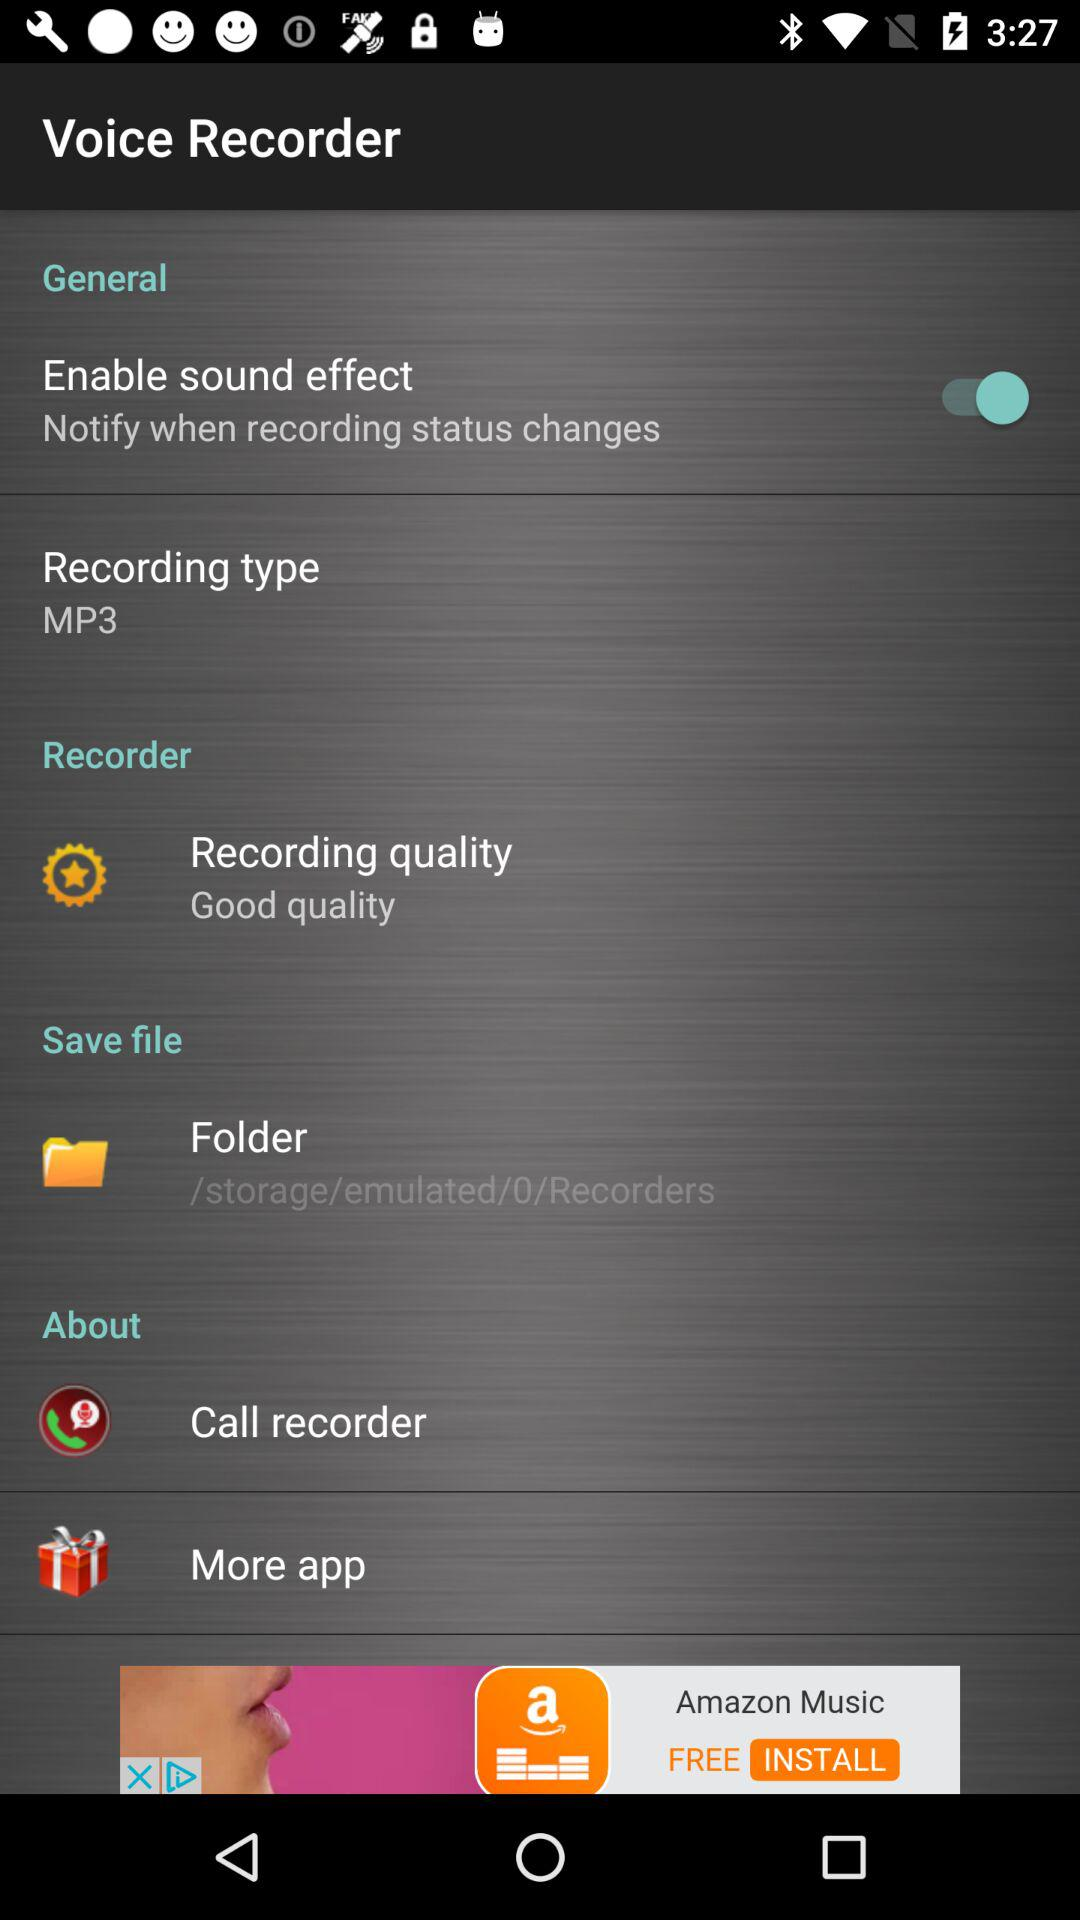What is the status of "Enable sound effect"? The status of "Enable sound effect" is "on". 